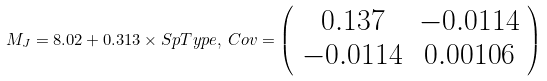Convert formula to latex. <formula><loc_0><loc_0><loc_500><loc_500>M _ { J } = 8 . 0 2 + 0 . 3 1 3 \times S p T y p e , \, C o v = \left ( \begin{array} { c c } 0 . 1 3 7 & - 0 . 0 1 1 4 \\ - 0 . 0 1 1 4 & 0 . 0 0 1 0 6 \\ \end{array} \right )</formula> 